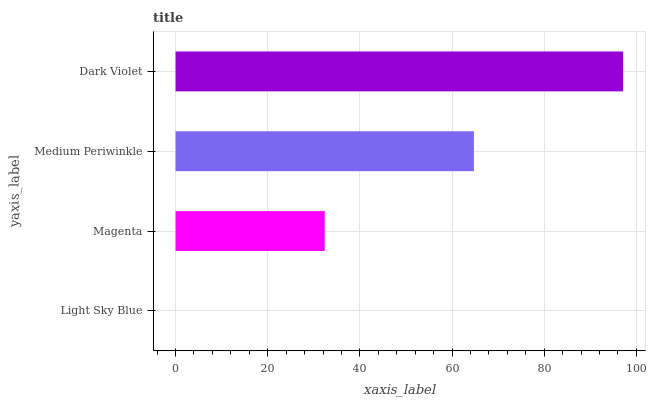Is Light Sky Blue the minimum?
Answer yes or no. Yes. Is Dark Violet the maximum?
Answer yes or no. Yes. Is Magenta the minimum?
Answer yes or no. No. Is Magenta the maximum?
Answer yes or no. No. Is Magenta greater than Light Sky Blue?
Answer yes or no. Yes. Is Light Sky Blue less than Magenta?
Answer yes or no. Yes. Is Light Sky Blue greater than Magenta?
Answer yes or no. No. Is Magenta less than Light Sky Blue?
Answer yes or no. No. Is Medium Periwinkle the high median?
Answer yes or no. Yes. Is Magenta the low median?
Answer yes or no. Yes. Is Magenta the high median?
Answer yes or no. No. Is Medium Periwinkle the low median?
Answer yes or no. No. 